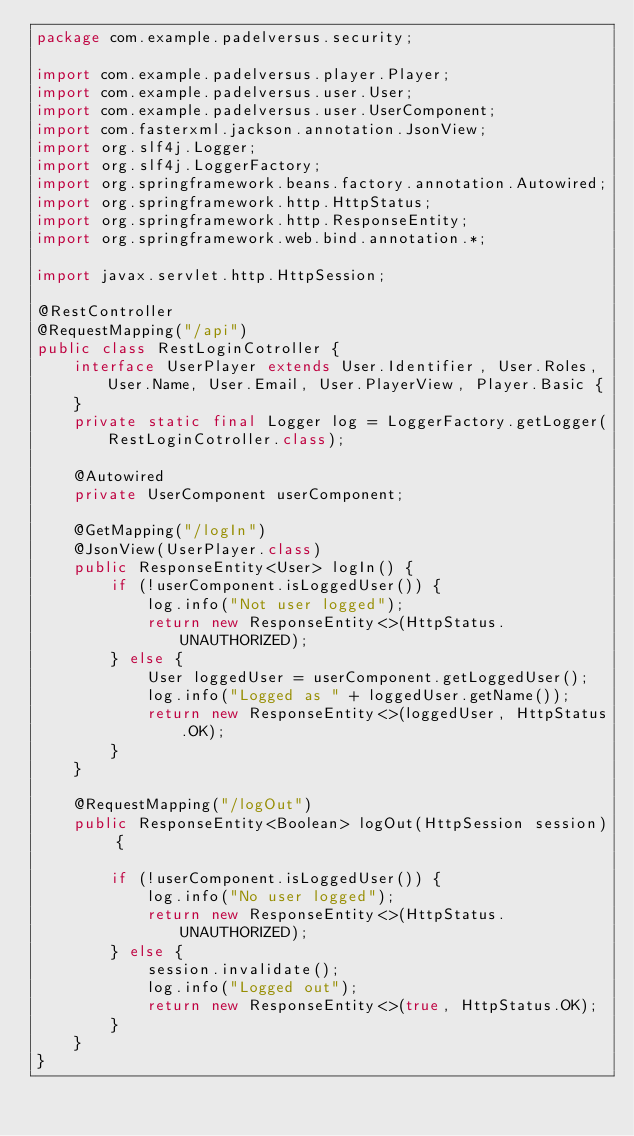<code> <loc_0><loc_0><loc_500><loc_500><_Java_>package com.example.padelversus.security;

import com.example.padelversus.player.Player;
import com.example.padelversus.user.User;
import com.example.padelversus.user.UserComponent;
import com.fasterxml.jackson.annotation.JsonView;
import org.slf4j.Logger;
import org.slf4j.LoggerFactory;
import org.springframework.beans.factory.annotation.Autowired;
import org.springframework.http.HttpStatus;
import org.springframework.http.ResponseEntity;
import org.springframework.web.bind.annotation.*;

import javax.servlet.http.HttpSession;

@RestController
@RequestMapping("/api")
public class RestLoginCotroller {
    interface UserPlayer extends User.Identifier, User.Roles, User.Name, User.Email, User.PlayerView, Player.Basic {
    }
    private static final Logger log = LoggerFactory.getLogger(RestLoginCotroller.class);

    @Autowired
    private UserComponent userComponent;

    @GetMapping("/logIn")
    @JsonView(UserPlayer.class)
    public ResponseEntity<User> logIn() {
        if (!userComponent.isLoggedUser()) {
            log.info("Not user logged");
            return new ResponseEntity<>(HttpStatus.UNAUTHORIZED);
        } else {
            User loggedUser = userComponent.getLoggedUser();
            log.info("Logged as " + loggedUser.getName());
            return new ResponseEntity<>(loggedUser, HttpStatus.OK);
        }
    }

    @RequestMapping("/logOut")
    public ResponseEntity<Boolean> logOut(HttpSession session) {

        if (!userComponent.isLoggedUser()) {
            log.info("No user logged");
            return new ResponseEntity<>(HttpStatus.UNAUTHORIZED);
        } else {
            session.invalidate();
            log.info("Logged out");
            return new ResponseEntity<>(true, HttpStatus.OK);
        }
    }
}
</code> 